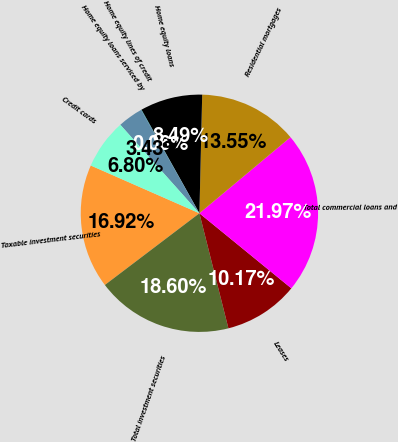Convert chart. <chart><loc_0><loc_0><loc_500><loc_500><pie_chart><fcel>Taxable investment securities<fcel>Total investment securities<fcel>Leases<fcel>Total commercial loans and<fcel>Residential mortgages<fcel>Home equity loans<fcel>Home equity lines of credit<fcel>Home equity loans serviced by<fcel>Credit cards<nl><fcel>16.92%<fcel>18.6%<fcel>10.17%<fcel>21.97%<fcel>13.55%<fcel>8.49%<fcel>0.06%<fcel>3.43%<fcel>6.8%<nl></chart> 